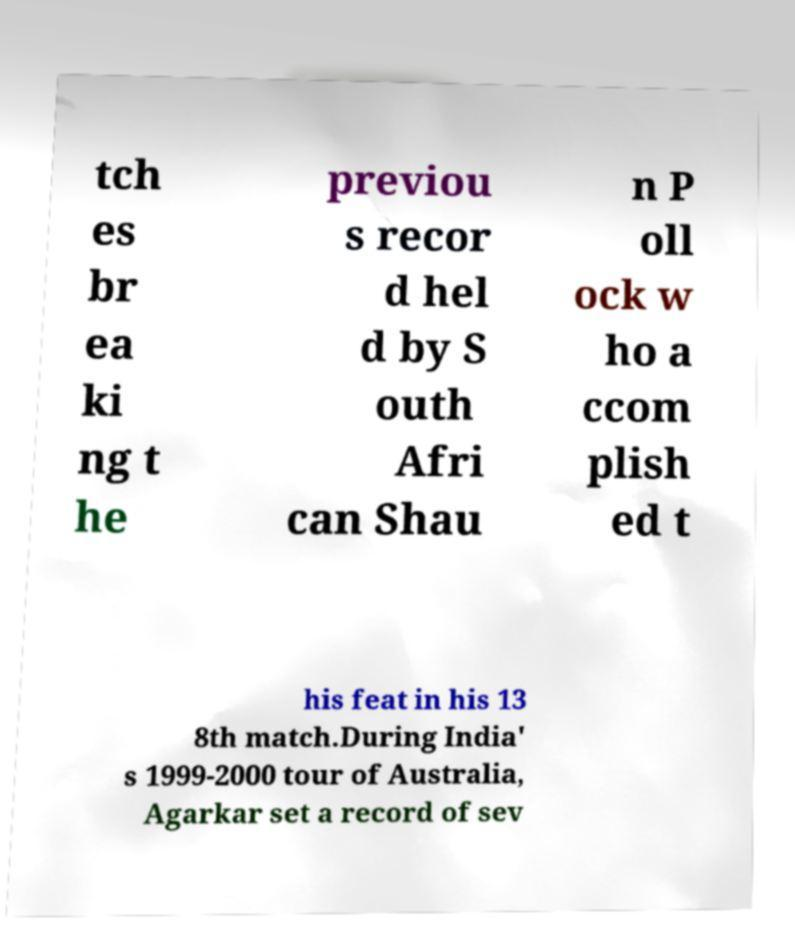Could you extract and type out the text from this image? tch es br ea ki ng t he previou s recor d hel d by S outh Afri can Shau n P oll ock w ho a ccom plish ed t his feat in his 13 8th match.During India' s 1999-2000 tour of Australia, Agarkar set a record of sev 